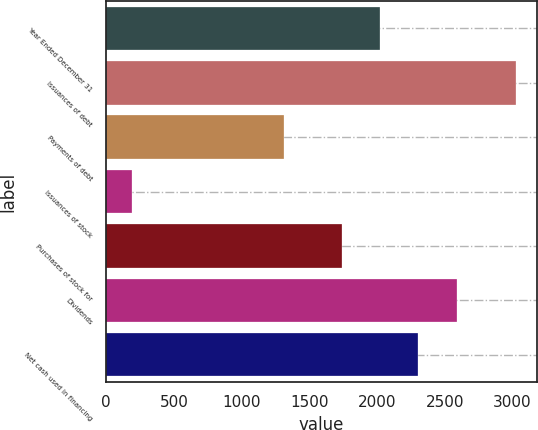Convert chart. <chart><loc_0><loc_0><loc_500><loc_500><bar_chart><fcel>Year Ended December 31<fcel>Issuances of debt<fcel>Payments of debt<fcel>Issuances of stock<fcel>Purchases of stock for<fcel>Dividends<fcel>Net cash used in financing<nl><fcel>2022.7<fcel>3030<fcel>1316<fcel>193<fcel>1739<fcel>2590.1<fcel>2306.4<nl></chart> 